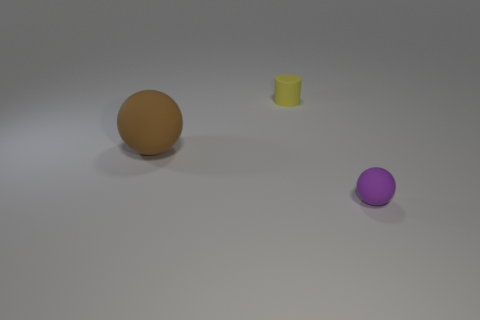What size is the thing that is right of the brown thing and on the left side of the tiny purple sphere?
Your response must be concise. Small. Are there any other things that are the same size as the brown rubber ball?
Your answer should be very brief. No. Are the cylinder and the small ball made of the same material?
Offer a very short reply. Yes. How many objects are either small things that are behind the big brown object or matte objects in front of the small cylinder?
Keep it short and to the point. 3. Is there another rubber sphere of the same size as the brown sphere?
Provide a succinct answer. No. What is the color of the other tiny object that is the same shape as the brown matte object?
Provide a succinct answer. Purple. Are there any big things that are behind the rubber ball that is on the left side of the cylinder?
Your answer should be compact. No. Do the rubber thing that is in front of the brown rubber thing and the big brown object have the same shape?
Provide a short and direct response. Yes. There is a yellow rubber object; what shape is it?
Give a very brief answer. Cylinder. What number of brown objects are the same material as the brown ball?
Provide a short and direct response. 0. 